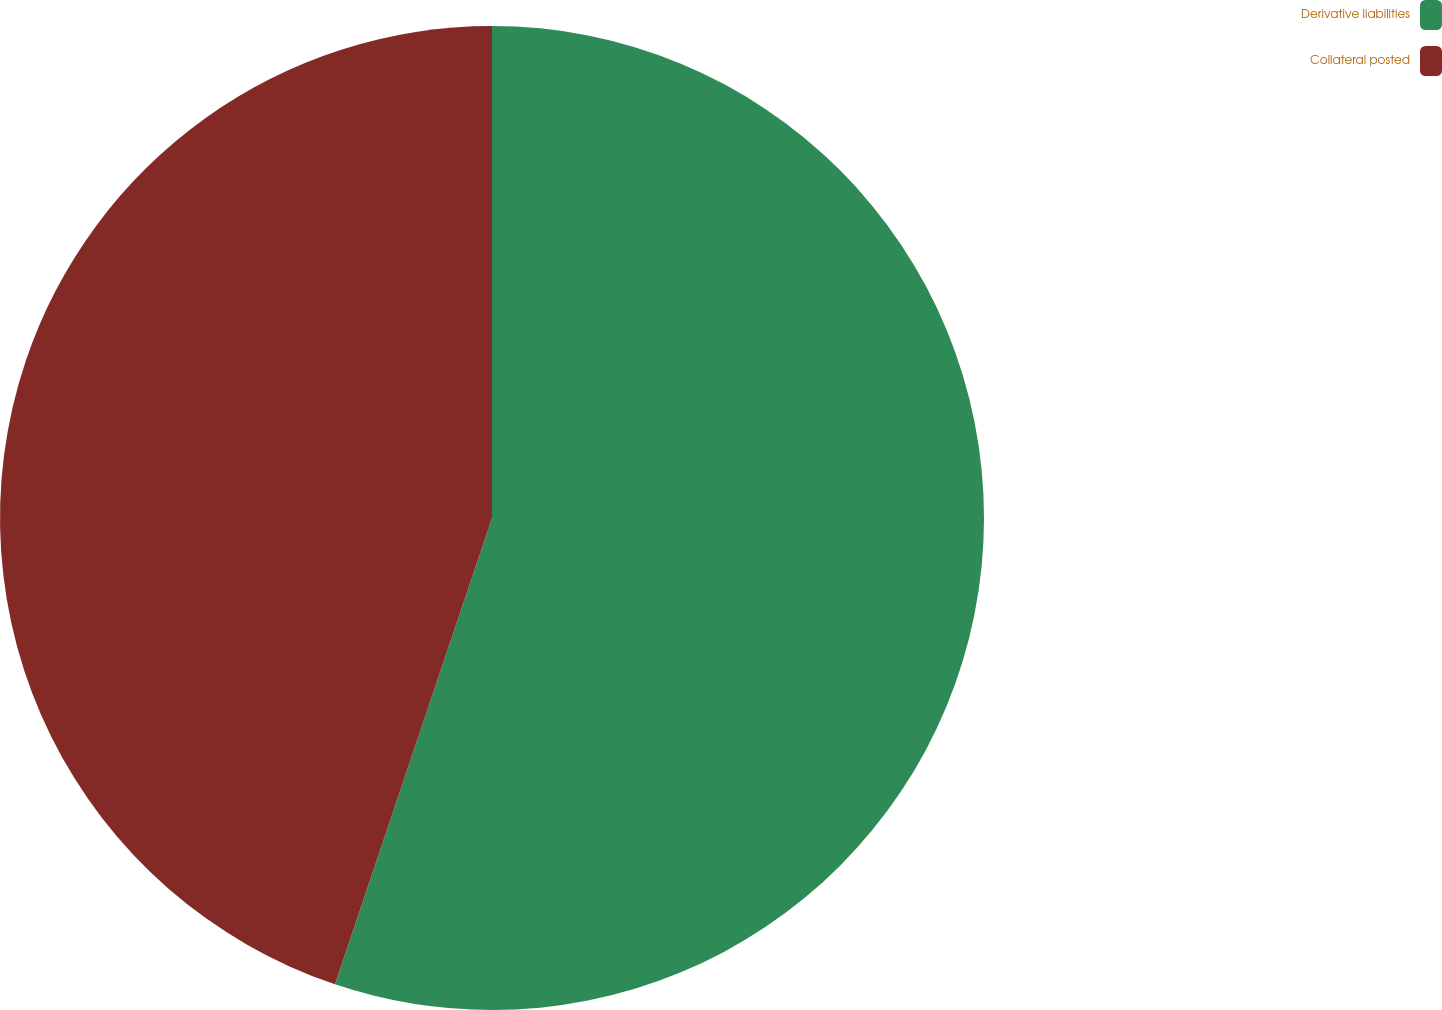<chart> <loc_0><loc_0><loc_500><loc_500><pie_chart><fcel>Derivative liabilities<fcel>Collateral posted<nl><fcel>55.17%<fcel>44.83%<nl></chart> 